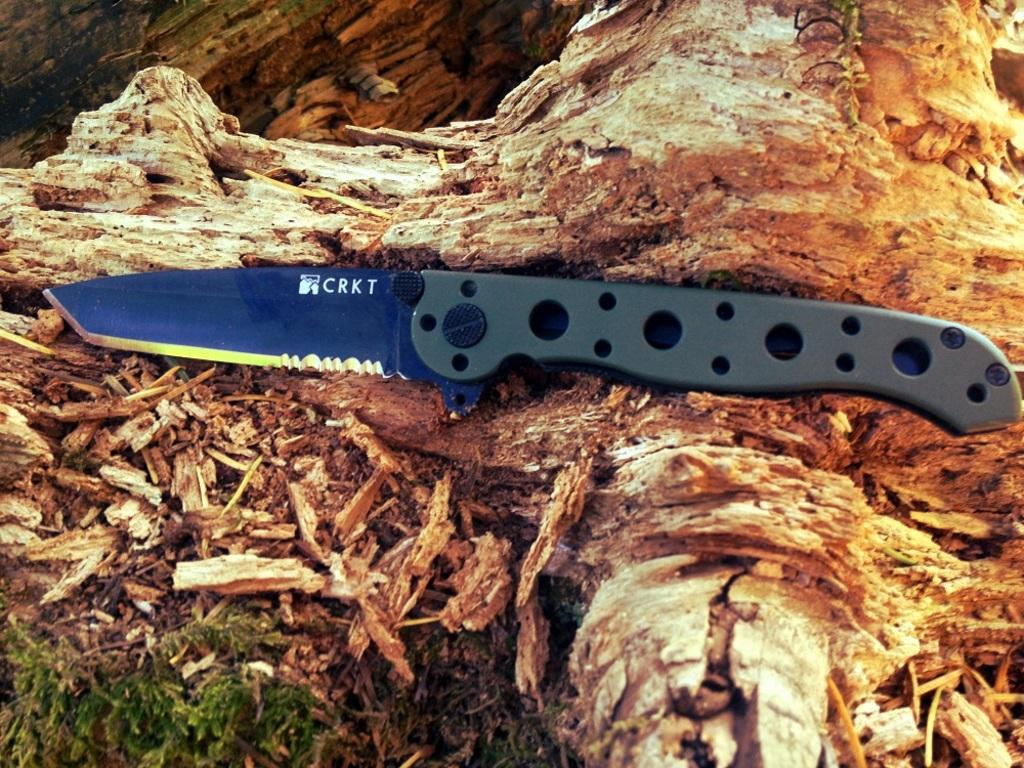What object is placed on the tree trunk in the image? There is a knife on a tree trunk in the image. What else can be seen related to the tree trunk in the image? There are pieces of tree trunk in the image. What type of vegetation is visible on the left side of the image? Grass is present on the left side of the image. What thought is expressed by the sugar in the image? There is no sugar present in the image, and therefore no thoughts can be attributed to it. 